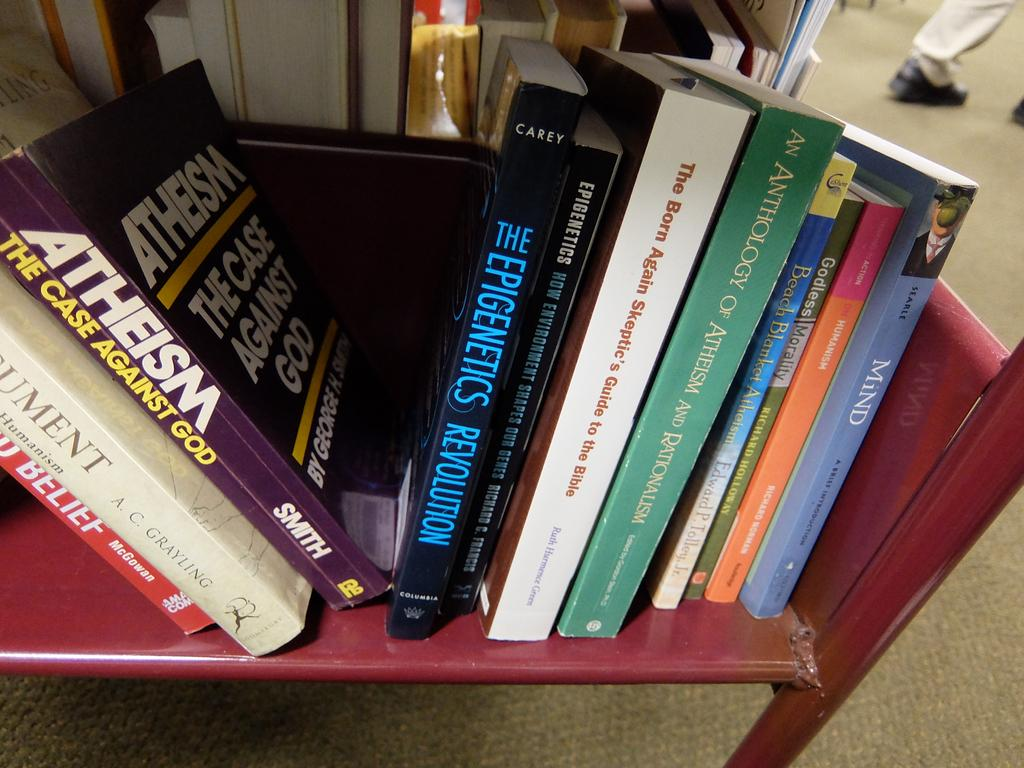<image>
Offer a succinct explanation of the picture presented. Books line a red shelf including one on Atheism. 